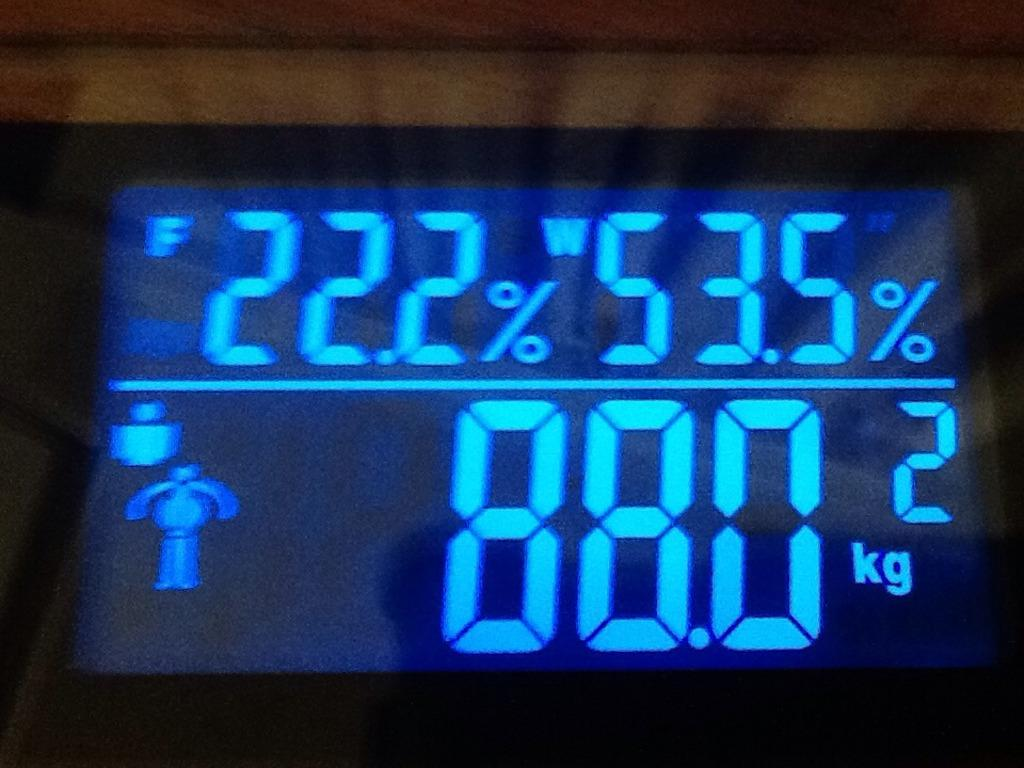<image>
Describe the image concisely. a scale display reading 88.9 kilograms in blue 